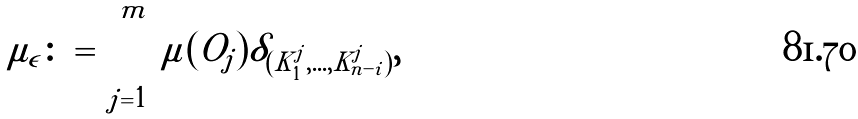Convert formula to latex. <formula><loc_0><loc_0><loc_500><loc_500>\mu _ { \epsilon } \colon = \sum _ { j = 1 } ^ { m } \mu ( O _ { j } ) \delta _ { ( K _ { 1 } ^ { j } , \dots , K _ { n - i } ^ { j } ) } ,</formula> 